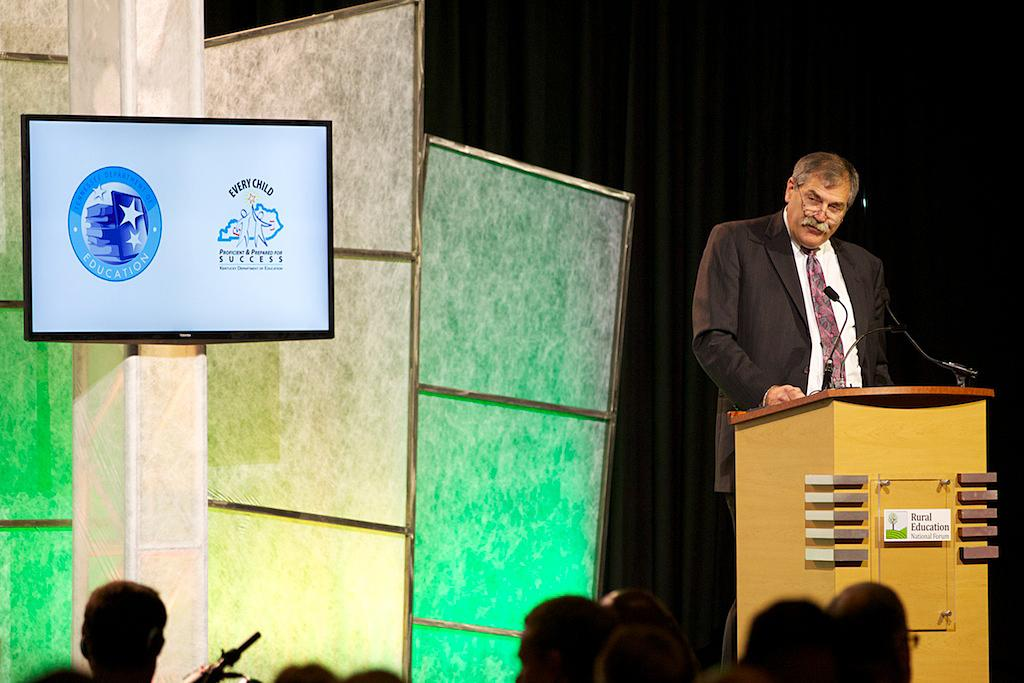Who is present in the image? There is a man in the image. What is the man wearing on his face? The man is wearing spectacles. What type of clothing is the man wearing on his upper body? The man is wearing a white shirt, a tie, and a blazer. What is the man standing near in the image? The man is standing near a podium. What is the large display device in the image? There is a screen in the image. What type of pump is visible in the image? There is no pump present in the image. How does the man rub zinc on his hands in the image? The man is not rubbing zinc on his hands in the image; he is wearing spectacles, a white shirt, a tie, and a blazer while standing near a podium. 